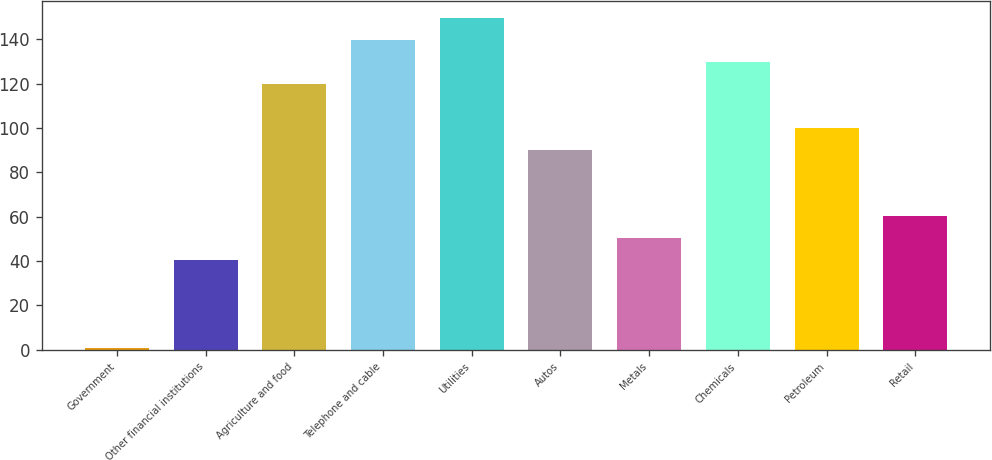Convert chart to OTSL. <chart><loc_0><loc_0><loc_500><loc_500><bar_chart><fcel>Government<fcel>Other financial institutions<fcel>Agriculture and food<fcel>Telephone and cable<fcel>Utilities<fcel>Autos<fcel>Metals<fcel>Chemicals<fcel>Petroleum<fcel>Retail<nl><fcel>0.63<fcel>40.39<fcel>119.91<fcel>139.79<fcel>149.73<fcel>90.09<fcel>50.33<fcel>129.85<fcel>100.03<fcel>60.27<nl></chart> 